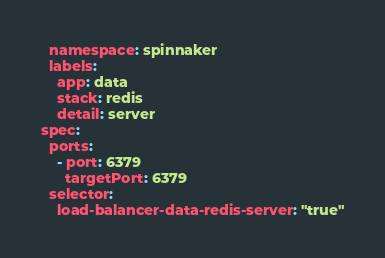Convert code to text. <code><loc_0><loc_0><loc_500><loc_500><_YAML_>  namespace: spinnaker
  labels:
    app: data
    stack: redis
    detail: server
spec:
  ports:
    - port: 6379
      targetPort: 6379
  selector:
    load-balancer-data-redis-server: "true"
</code> 